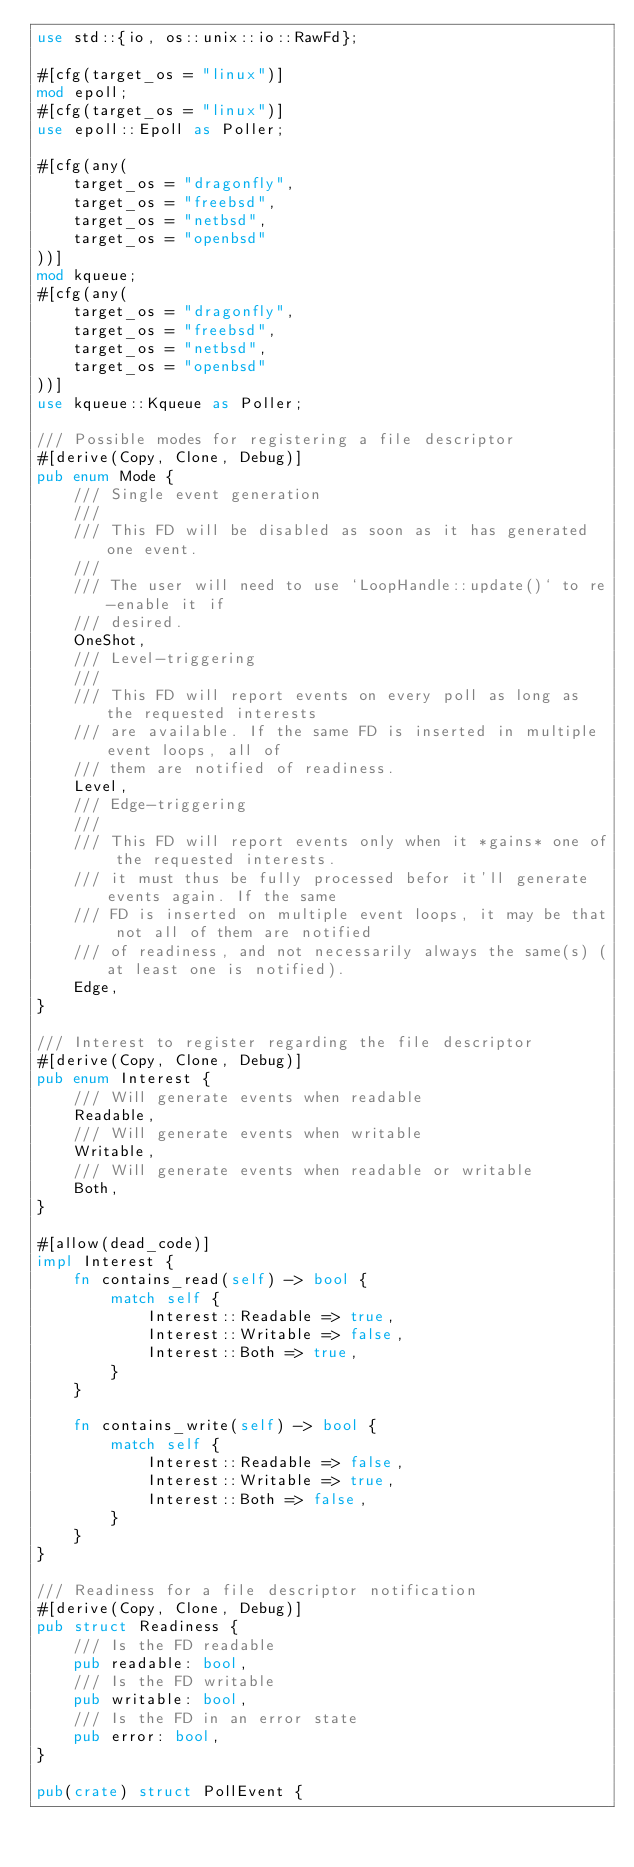Convert code to text. <code><loc_0><loc_0><loc_500><loc_500><_Rust_>use std::{io, os::unix::io::RawFd};

#[cfg(target_os = "linux")]
mod epoll;
#[cfg(target_os = "linux")]
use epoll::Epoll as Poller;

#[cfg(any(
    target_os = "dragonfly",
    target_os = "freebsd",
    target_os = "netbsd",
    target_os = "openbsd"
))]
mod kqueue;
#[cfg(any(
    target_os = "dragonfly",
    target_os = "freebsd",
    target_os = "netbsd",
    target_os = "openbsd"
))]
use kqueue::Kqueue as Poller;

/// Possible modes for registering a file descriptor
#[derive(Copy, Clone, Debug)]
pub enum Mode {
    /// Single event generation
    ///
    /// This FD will be disabled as soon as it has generated one event.
    ///
    /// The user will need to use `LoopHandle::update()` to re-enable it if
    /// desired.
    OneShot,
    /// Level-triggering
    ///
    /// This FD will report events on every poll as long as the requested interests
    /// are available. If the same FD is inserted in multiple event loops, all of
    /// them are notified of readiness.
    Level,
    /// Edge-triggering
    ///
    /// This FD will report events only when it *gains* one of the requested interests.
    /// it must thus be fully processed befor it'll generate events again. If the same
    /// FD is inserted on multiple event loops, it may be that not all of them are notified
    /// of readiness, and not necessarily always the same(s) (at least one is notified).
    Edge,
}

/// Interest to register regarding the file descriptor
#[derive(Copy, Clone, Debug)]
pub enum Interest {
    /// Will generate events when readable
    Readable,
    /// Will generate events when writable
    Writable,
    /// Will generate events when readable or writable
    Both,
}

#[allow(dead_code)]
impl Interest {
    fn contains_read(self) -> bool {
        match self {
            Interest::Readable => true,
            Interest::Writable => false,
            Interest::Both => true,
        }
    }

    fn contains_write(self) -> bool {
        match self {
            Interest::Readable => false,
            Interest::Writable => true,
            Interest::Both => false,
        }
    }
}

/// Readiness for a file descriptor notification
#[derive(Copy, Clone, Debug)]
pub struct Readiness {
    /// Is the FD readable
    pub readable: bool,
    /// Is the FD writable
    pub writable: bool,
    /// Is the FD in an error state
    pub error: bool,
}

pub(crate) struct PollEvent {</code> 